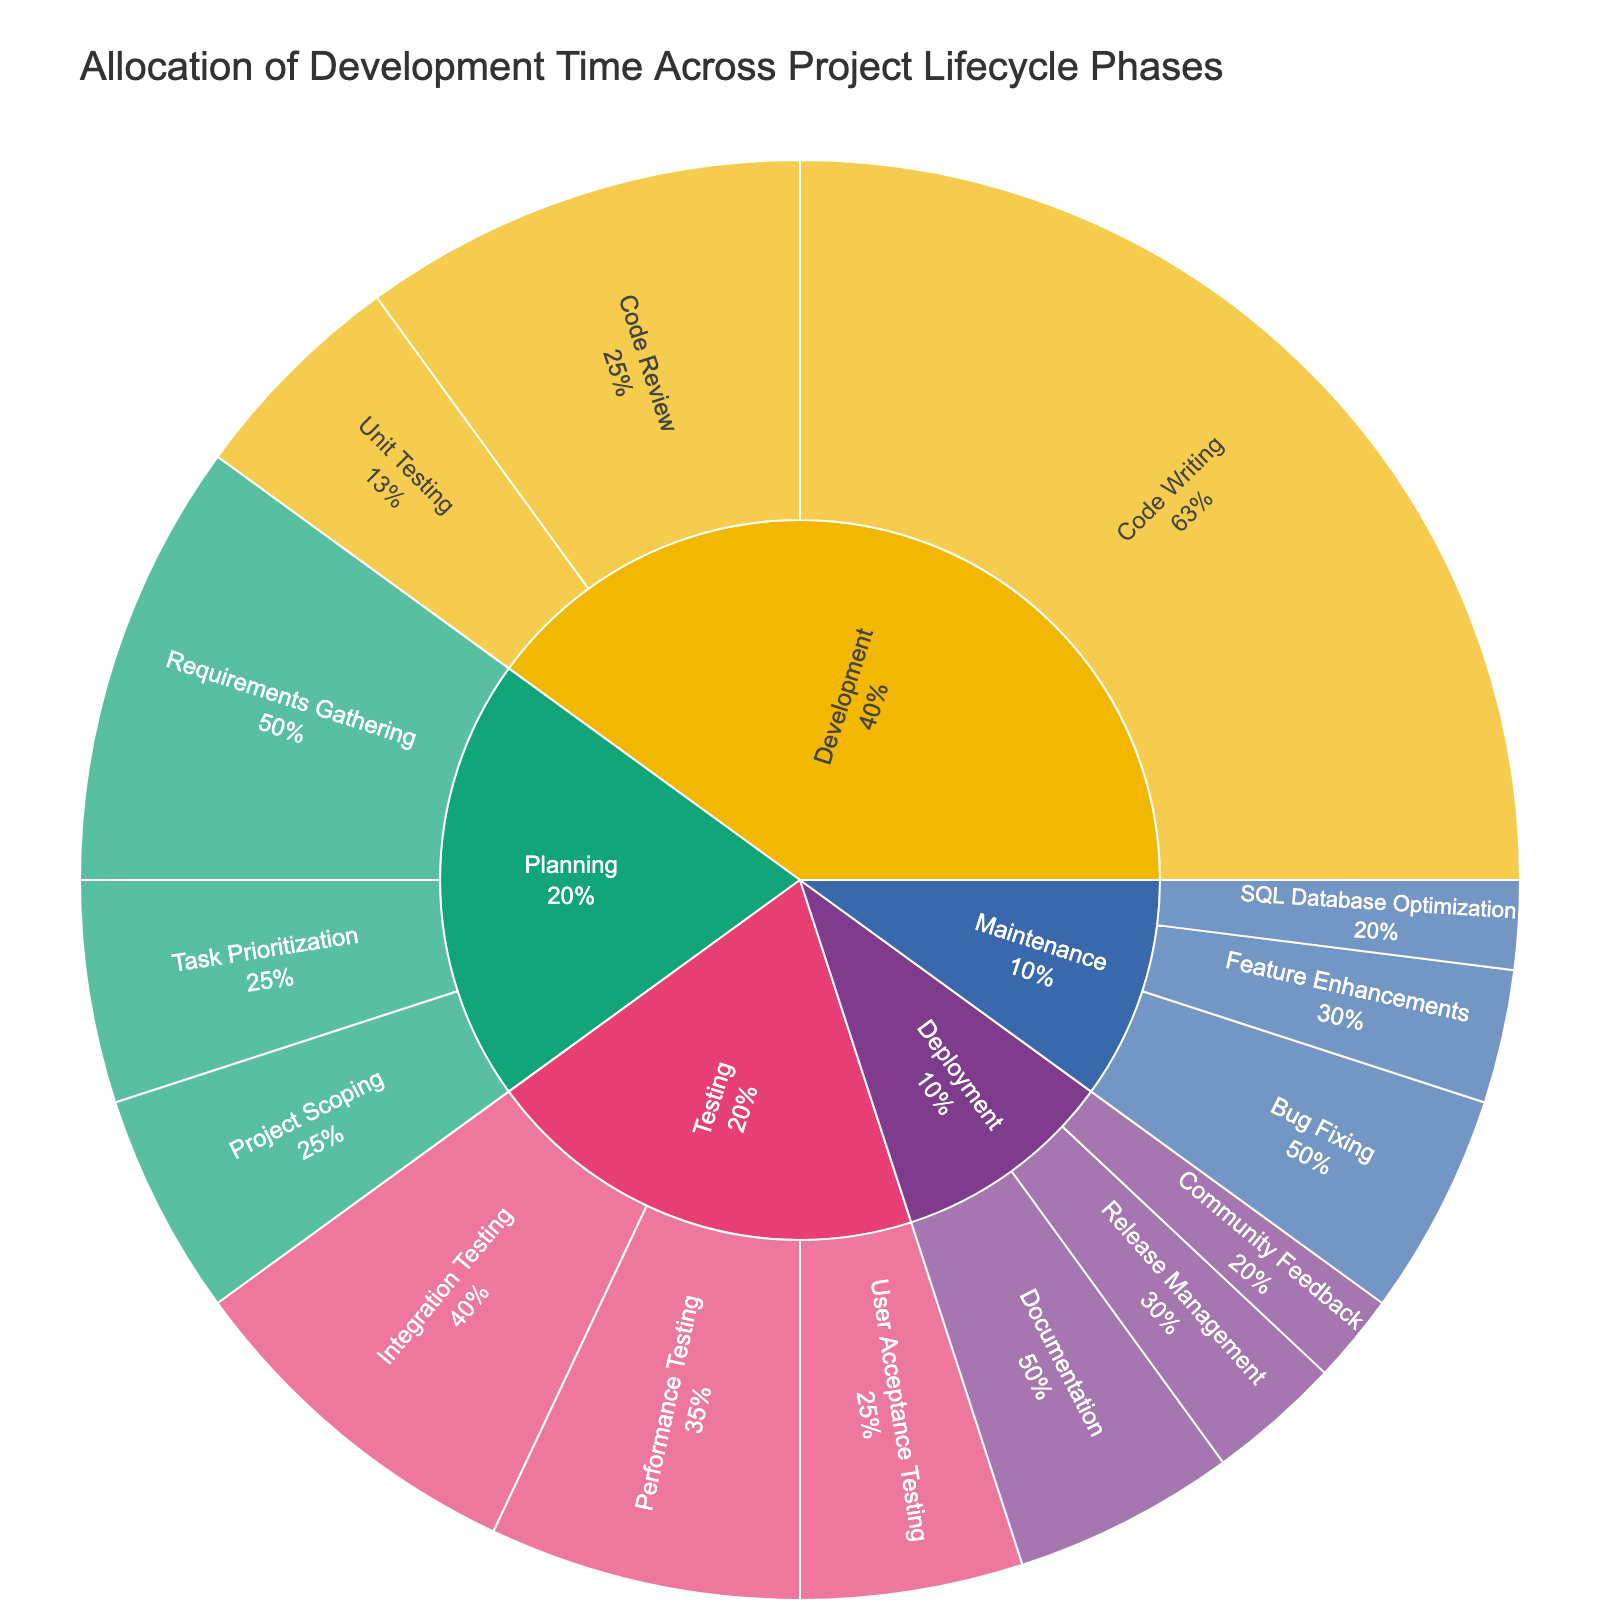What is the title of the sunburst plot? The title is prominently displayed at the top of the plot. It provides an overview of what the plot represents. In this case, it indicates the focus on development time allocation across different project phases.
Answer: Allocation of Development Time Across Project Lifecycle Phases Which phase has the highest percentage of development time allocation? Looking at the sunburst plot, identify which phase (the outermost layer corresponding to a high-level category) encompasses the largest portion of the circle.
Answer: Development How much development time is allocated to Code Writing? Within the Development phase, locate the section labeled Code Writing. The percentage is displayed either within the plot section or via hover information.
Answer: 25% What is the combined percentage of all Testing subphases? Add the percentages of Integration Testing, Performance Testing, and User Acceptance Testing. These values are all subphases of Testing. Calculation: 8 + 7 + 5 = 20.
Answer: 20% Which subphase within the Planning phase has the smallest allocation of development time? Within the Planning phase, compare the percentages of Requirements Gathering, Project Scoping, and Task Prioritization. The smallest value indicates the subphase with the least time allocation.
Answer: Project Scoping Compare the total percentage of time spent in Deployment with that in Maintenance. Which one is higher? Sum the percentages of all subphases within Deployment and Maintenance, then compare the totals. Calculation for Deployment: 5 + 3 + 2 = 10. Calculation for Maintenance: 5 + 3 + 2 = 10. Since both are equal, neither is higher.
Answer: Neither What fraction of the entire time is spent on Bug Fixing within the Maintenance phase? Identify the percentage value for Bug Fixing within Maintenance, then translate this percentage into a fraction of the whole (100%). Calculation: 5/100 = 1/20.
Answer: 1/20 What is the percentage difference between Code Review and Unit Testing in the Development phase? Subtract the lower percentage (Unit Testing) from the higher percentage (Code Review) within the Development phase. Calculation: 10 - 5 = 5.
Answer: 5% How much more time is allocated to User Acceptance Testing compared to SQL Database Optimization? Subtract the percentage of SQL Database Optimization from the percentage of User Acceptance Testing. Calculation: 5 - 2 = 3.
Answer: 3% Name all phases that have subphases with a percentage allocation of 5% or higher. Identify all subphases in each primary phase (outer ring of the sunburst), and check which ones have 5% or higher. Return the respective primary phases.
Answer: Planning, Development, Testing, Deployment, Maintenance 